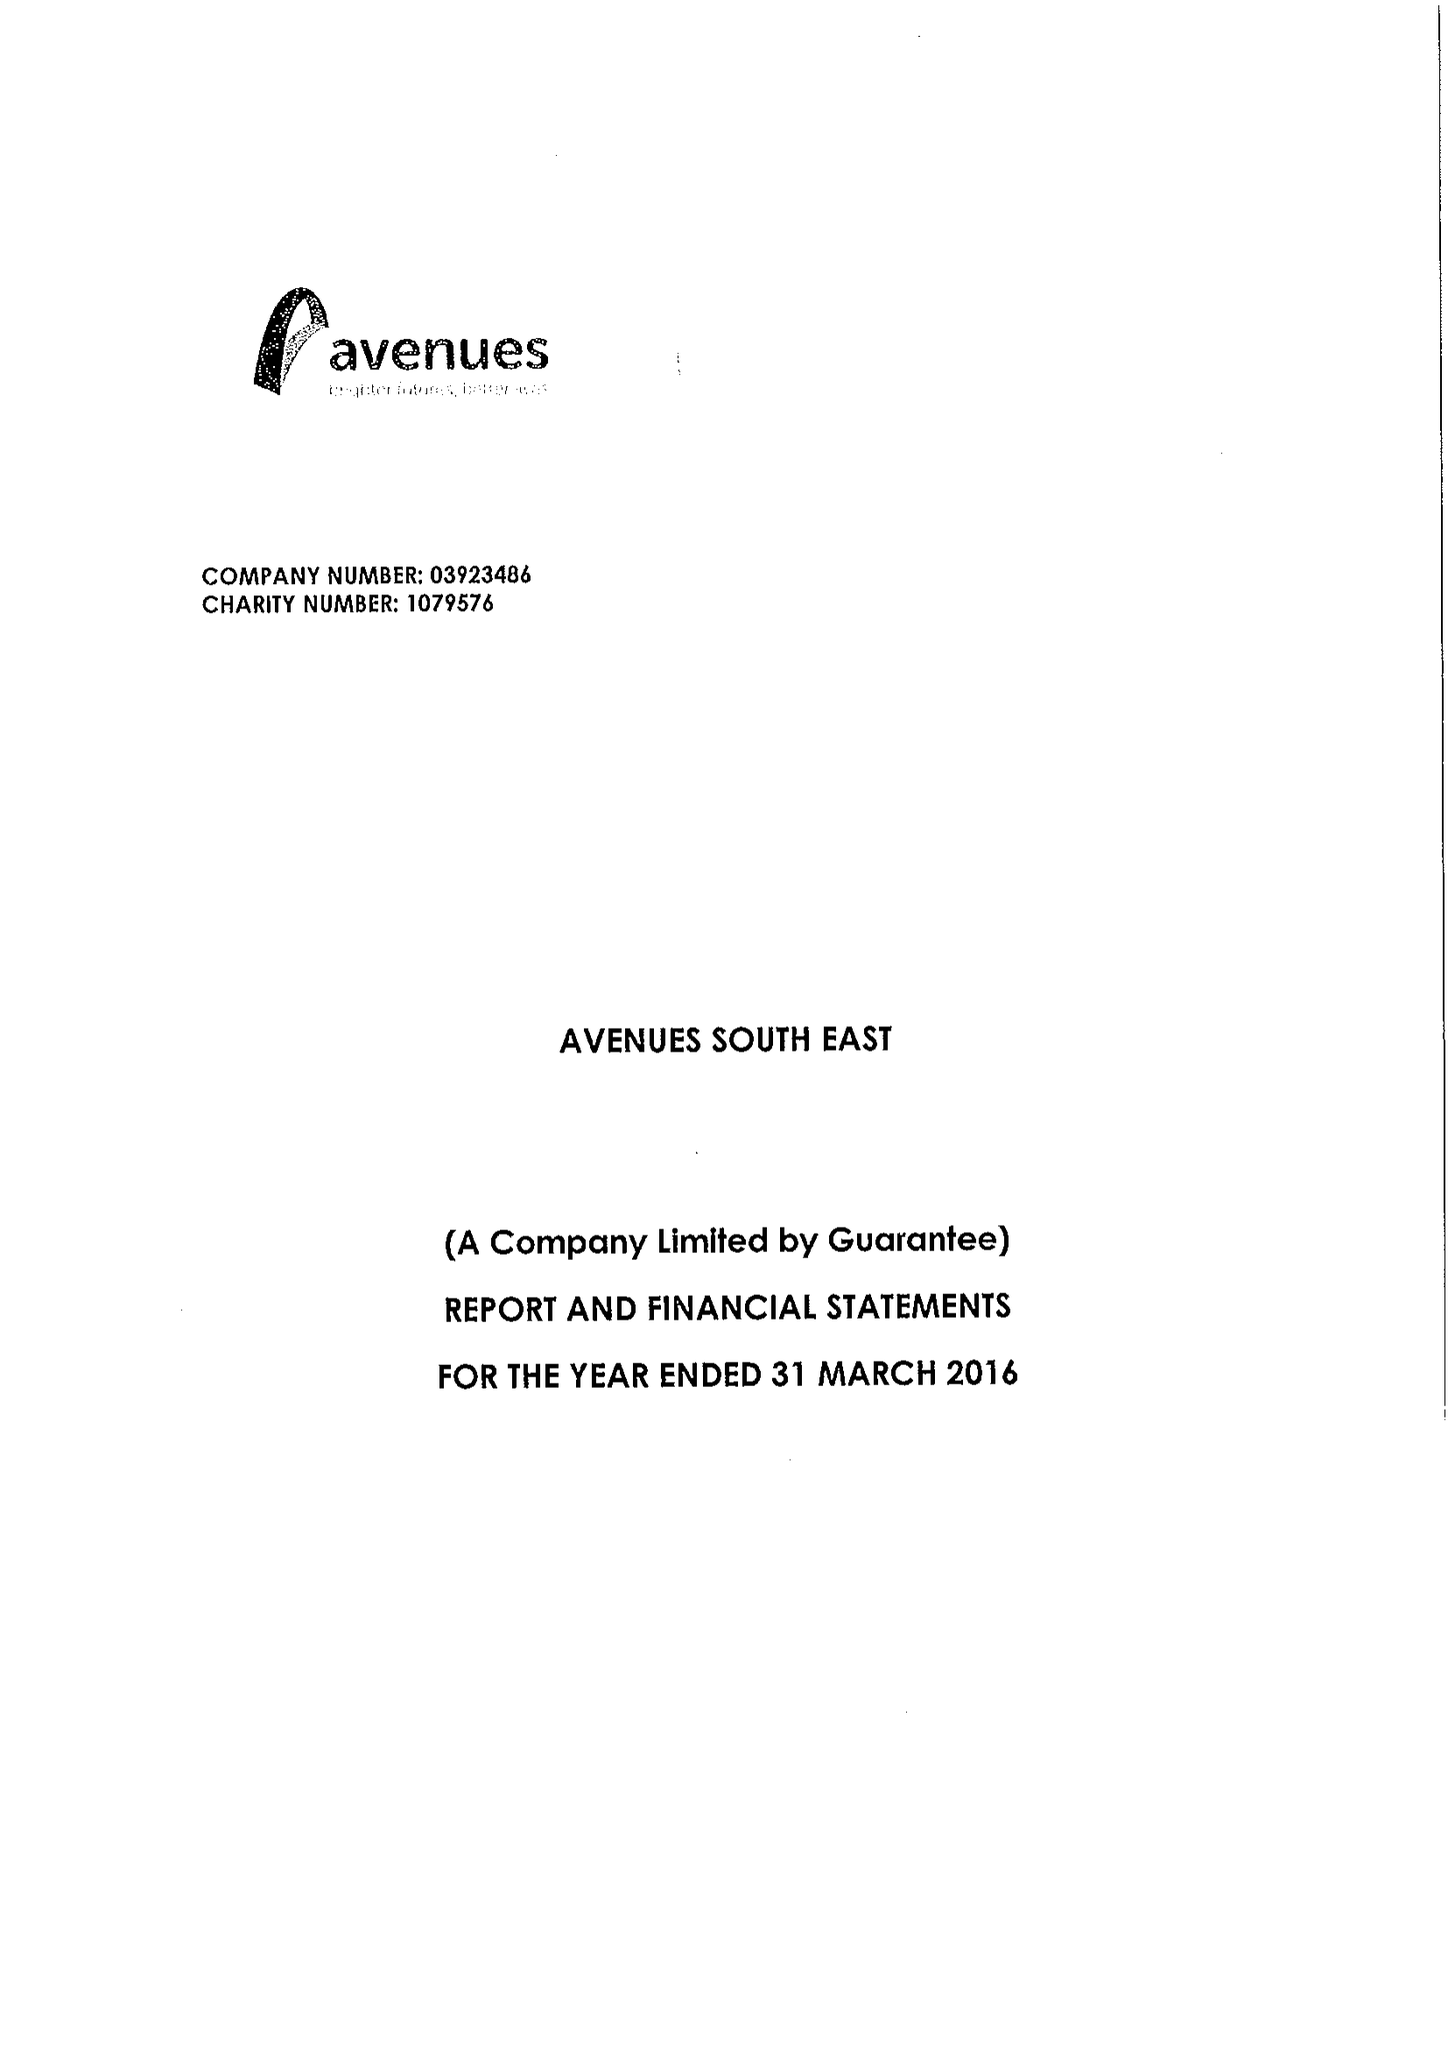What is the value for the income_annually_in_british_pounds?
Answer the question using a single word or phrase. 14508804.00 